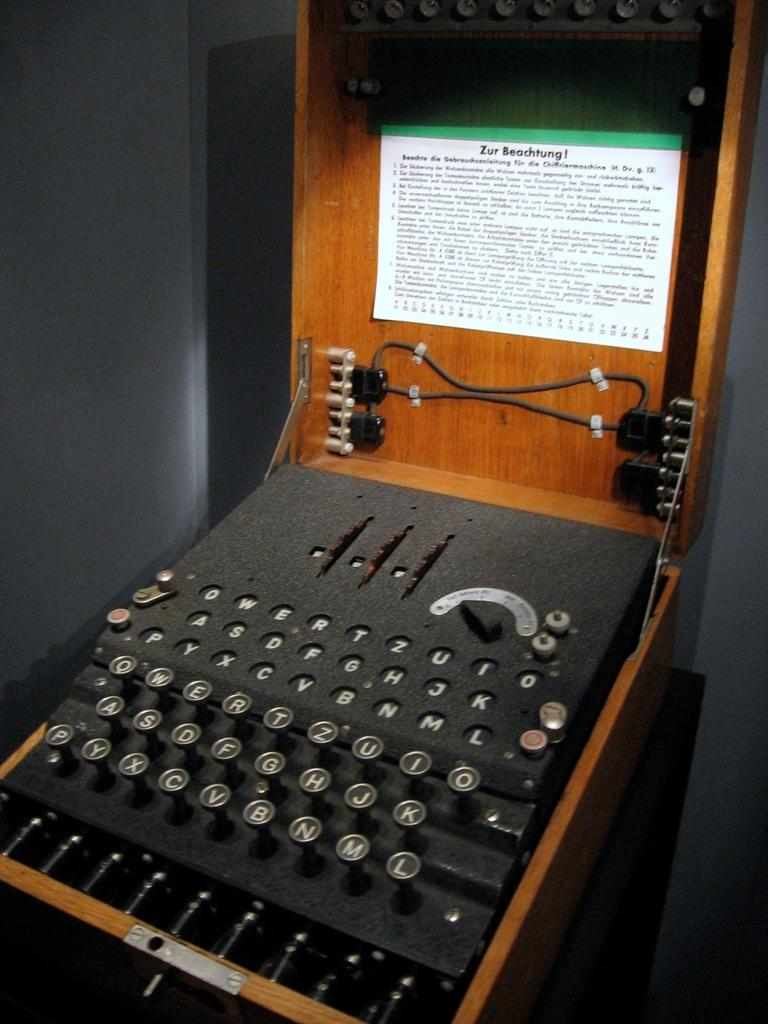<image>
Summarize the visual content of the image. A brown and black typewrite with the words Zur Beachtung is shown. 